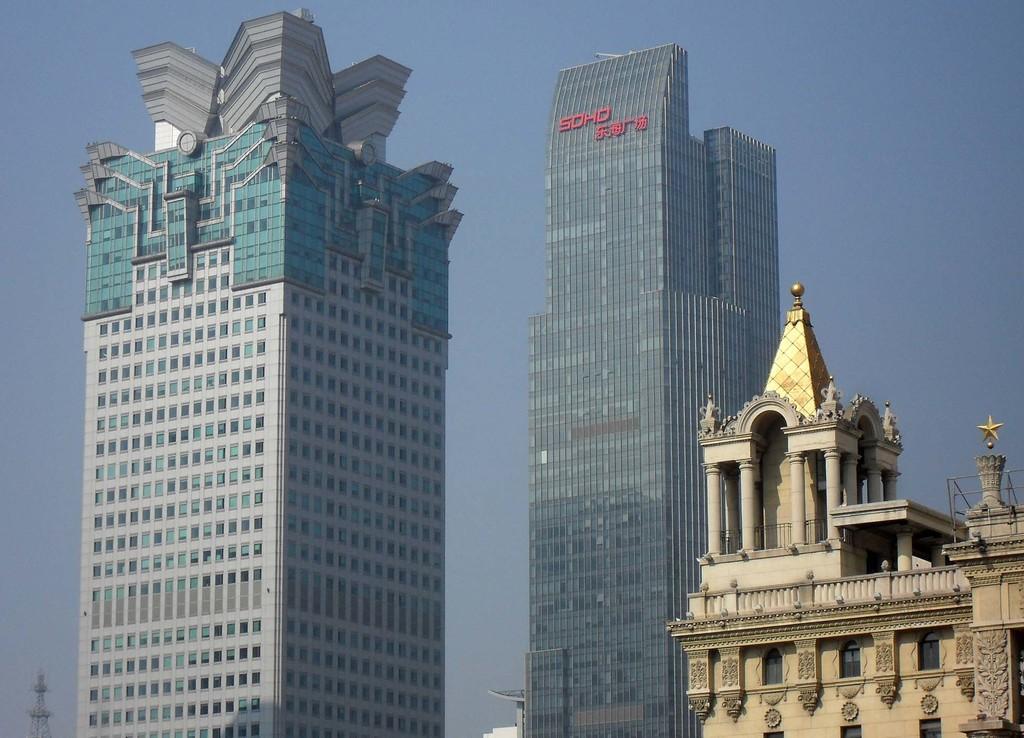Describe this image in one or two sentences. In this image there are few buildings. Left bottom there is a tower. Behind buildings there is sky. 